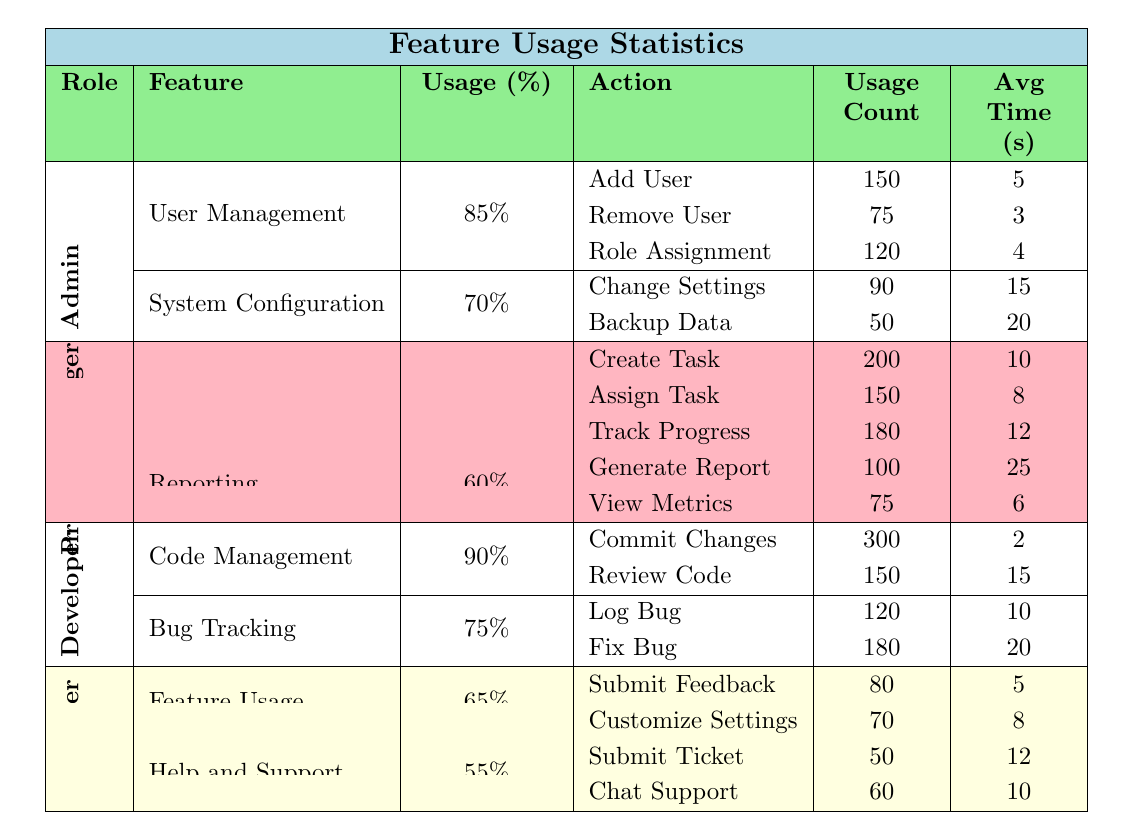What's the usage percentage for the Developer role in Code Management? The usage percentage for the Developer role in Code Management can be found in the table directly under the Developer section. It indicates a usage percentage of 90%.
Answer: 90% Which action has the highest usage count within the Project Manager's Task Management feature? Looking at the Task Management feature under the Project Manager role, the actions listed are Create Task, Assign Task, and Track Progress. The usage counts for these actions are 200, 150, and 180, respectively, making Create Task the one with the highest count of 200.
Answer: Create Task What is the average time spent on actions in the Bug Tracking feature by Developers? The Bug Tracking feature consists of two actions: Log Bug (10 seconds) and Fix Bug (20 seconds). To find the average time, we sum the times (10 + 20 = 30) and divide by the number of actions (2), resulting in an average of 30/2 = 15 seconds.
Answer: 15 seconds Does the Admin role use the System Configuration feature more than the End User uses Help and Support? The Admin role has a usage percentage of 70% for System Configuration, while the End User has a usage percentage of 55% for Help and Support. Since 70% is greater than 55%, the Admin does use System Configuration more than the End User uses Help and Support.
Answer: Yes What is the total usage count of actions under the User Management feature? Under the User Management feature, the actions are Add User (150), Remove User (75), and Role Assignment (120). To find the total usage count, sum these values: 150 + 75 + 120 = 345.
Answer: 345 